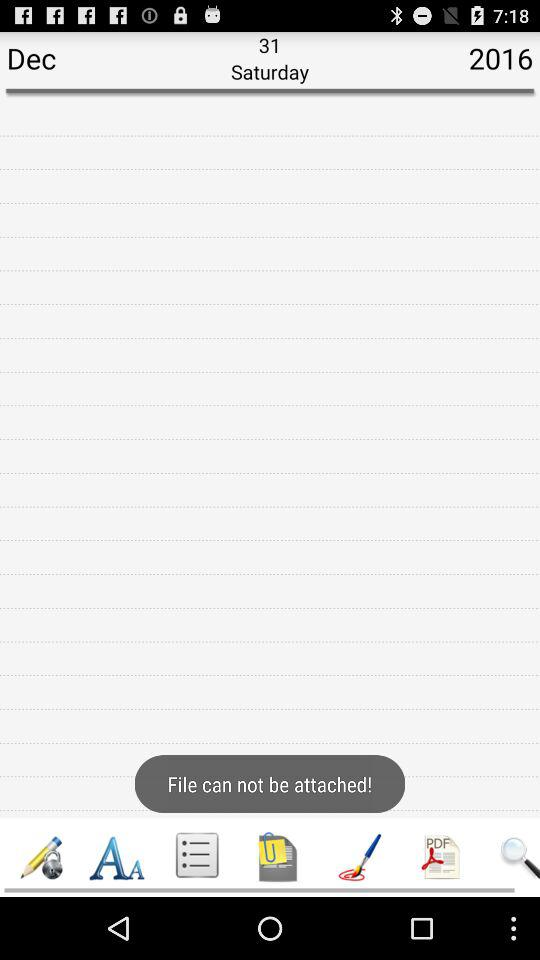Which tab is selected?
When the provided information is insufficient, respond with <no answer>. <no answer> 